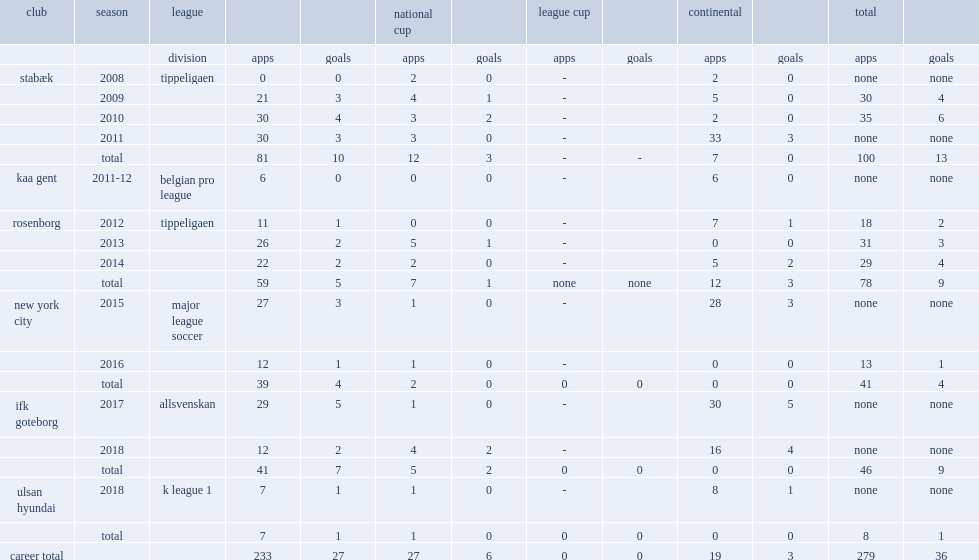Which club did diskerud play for in 2012? Rosenborg. 